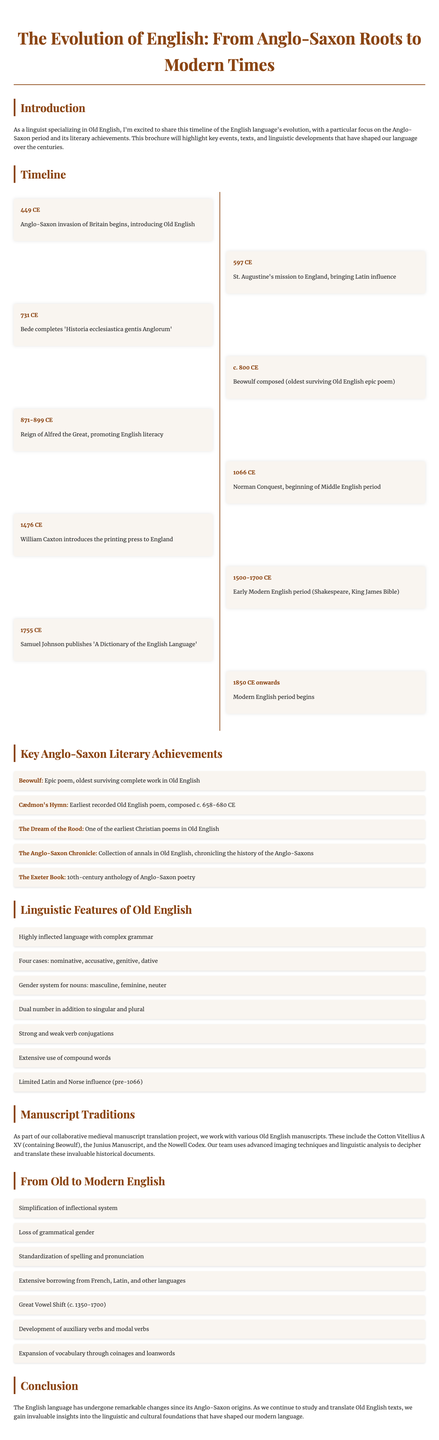What year does the Anglo-Saxon invasion of Britain begin? The document states that the Anglo-Saxon invasion of Britain begins in 449 CE.
Answer: 449 CE What is the title of the oldest surviving Old English epic poem? According to the document, the oldest surviving Old English epic poem is "Beowulf."
Answer: Beowulf Which king promoted English literacy during his reign? The document mentions that Alfred the Great promoted English literacy during his reign from 871 to 899 CE.
Answer: Alfred the Great What is one of the linguistic features of Old English? The document notes that Old English has a highly inflected language with complex grammar as one of its features.
Answer: Highly inflected language What work is described as the earliest recorded Old English poem? The document states that "Cædmon's Hymn" is the earliest recorded Old English poem.
Answer: Cædmon's Hymn How many cases does Old English have? The document specifies that Old English has four cases: nominative, accusative, genitive, and dative.
Answer: Four cases What document chronicles the history of the Anglo-Saxons? The document indicates that "The Anglo-Saxon Chronicle" is a collection chronicling the history of the Anglo-Saxons.
Answer: The Anglo-Saxon Chronicle What major event marks the beginning of the Middle English period? The document states that the Norman Conquest in 1066 CE marks the beginning of the Middle English period.
Answer: Norman Conquest What does the conclusion highlight about the changes in the English language? The conclusion emphasizes that the English language has undergone remarkable changes since its Anglo-Saxon origins.
Answer: Remarkable changes 